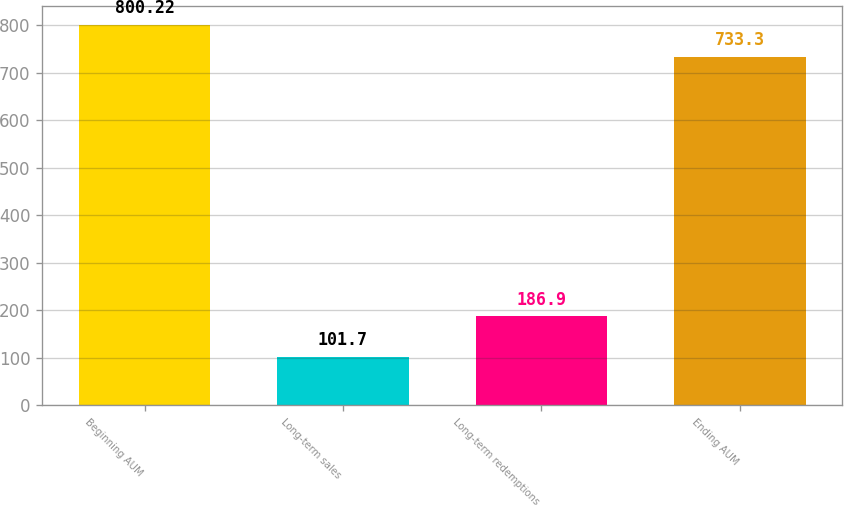<chart> <loc_0><loc_0><loc_500><loc_500><bar_chart><fcel>Beginning AUM<fcel>Long-term sales<fcel>Long-term redemptions<fcel>Ending AUM<nl><fcel>800.22<fcel>101.7<fcel>186.9<fcel>733.3<nl></chart> 